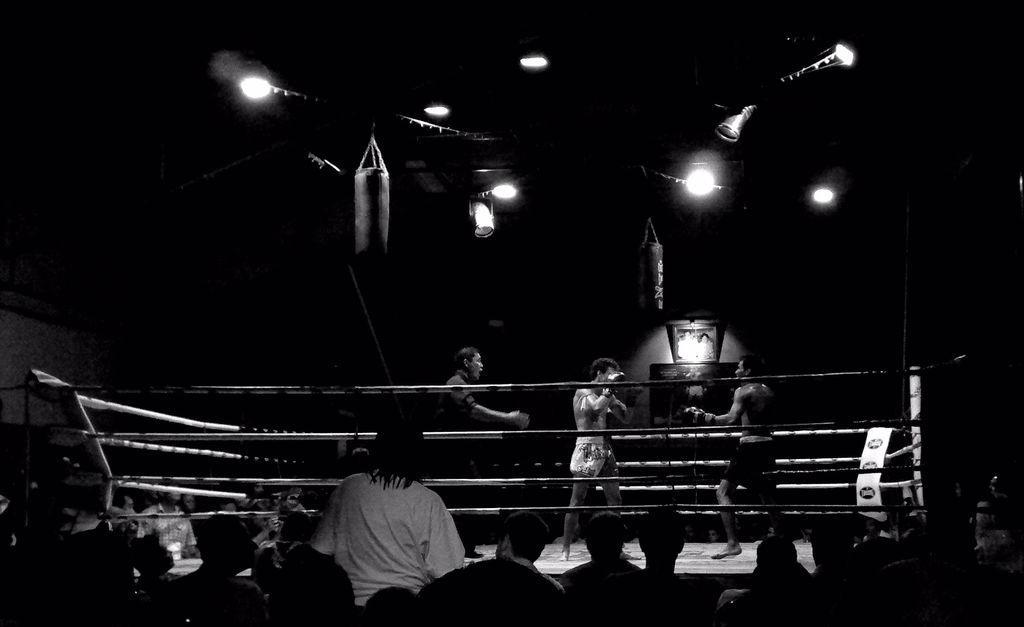How would you summarize this image in a sentence or two? At the bottom of this image, there are persons. In front of them, there are three persons on a stage, which is having a fence. Above them, there are lights and other objects attached to the roof. And the background is dark in color. 